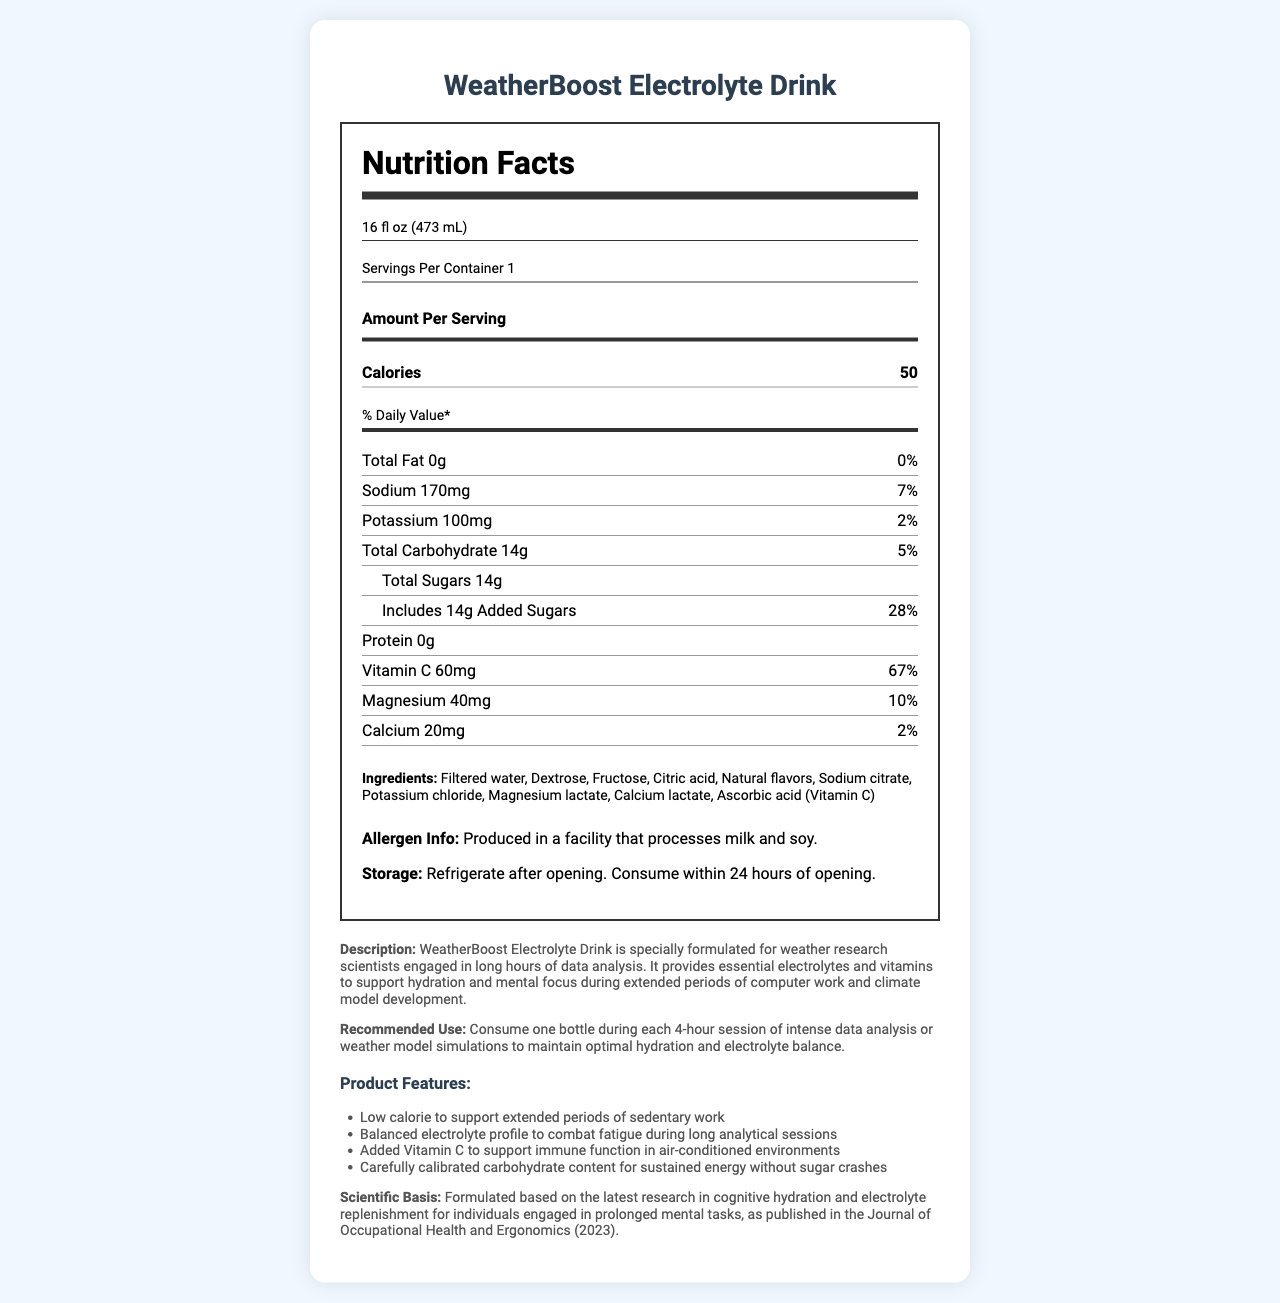What is the serving size of WeatherBoost Electrolyte Drink? The serving size is directly indicated at the top of the Nutrition Facts section.
Answer: 16 fl oz (473 mL) How many calories are in one serving of WeatherBoost Electrolyte Drink? The calorie count per serving is listed under "Amount Per Serving."
Answer: 50 What is the total amount of sugars in this drink? The amount of total sugars is mentioned under the section for Total Carbohydrate.
Answer: 14g What percentage of the daily value of Vitamin C does one serving provide? The daily value percentage of Vitamin C is listed alongside its amount in milligrams.
Answer: 67% How should WeatherBoost Electrolyte Drink be stored after opening? The storage instructions are given in the document's allergen and storage section.
Answer: Refrigerate after opening. Consume within 24 hours of opening. How much sodium is present in one serving? A. 50mg B. 170mg C. 200mg D. 300mg The amount of sodium is listed as 170mg in the Nutrition Facts.
Answer: B What kind of flavors are added to WeatherBoost Electrolyte Drink? A. Artificial flavors B. Natural flavors C. No added flavors The ingredients list includes "Natural flavors."
Answer: B Which of the following is NOT a feature of WeatherBoost Electrolyte Drink? A. Low calorie B. High caffeine content C. Balanced electrolyte profile D. Added Vitamin C The features section lists low calorie, balanced electrolyte profile, and added Vitamin C, but does not mention high caffeine content.
Answer: B Is WeatherBoost Electrolyte Drink suitable for someone avoiding soy? The allergen information states that it is produced in a facility that processes soy.
Answer: No Describe the main idea of the document. The document provides detailed nutrition facts, ingredients, storage instructions, and highlights the product's features and benefits for its target audience.
Answer: WeatherBoost Electrolyte Drink is a specialized beverage designed for weather research scientists engaged in long periods of data analysis. It offers hydration, balanced electrolytes, and essential vitamins to support mental focus and health. What is the scientific journal mentioned in the product description? The scientific basis section mentions the journal of Occupational Health and Ergonomics (2023).
Answer: Journal of Occupational Health and Ergonomics (2023) How many grams of protein are in one serving of WeatherBoost Electrolyte Drink? The protein content is clearly listed as 0g in the Nutrition Facts section.
Answer: 0g What is the primary purpose of WeatherBoost Electrolyte Drink according to the document? This purpose is explained in the product description.
Answer: To support hydration and mental focus during long hours of data analysis and climate model development for weather research scientists. What is the percentage of daily value for total fat in this drink? The daily value percentage for total fat is shown to be 0%.
Answer: 0% Does the document specify the price of WeatherBoost Electrolyte Drink? The document does not contain any pricing information.
Answer: Not enough information 